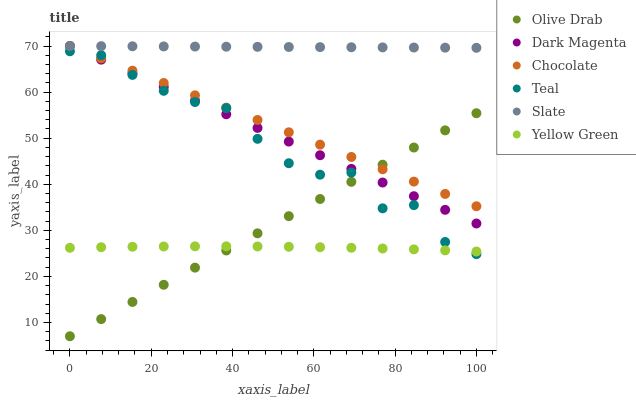Does Yellow Green have the minimum area under the curve?
Answer yes or no. Yes. Does Slate have the maximum area under the curve?
Answer yes or no. Yes. Does Chocolate have the minimum area under the curve?
Answer yes or no. No. Does Chocolate have the maximum area under the curve?
Answer yes or no. No. Is Olive Drab the smoothest?
Answer yes or no. Yes. Is Teal the roughest?
Answer yes or no. Yes. Is Slate the smoothest?
Answer yes or no. No. Is Slate the roughest?
Answer yes or no. No. Does Olive Drab have the lowest value?
Answer yes or no. Yes. Does Chocolate have the lowest value?
Answer yes or no. No. Does Dark Magenta have the highest value?
Answer yes or no. Yes. Does Teal have the highest value?
Answer yes or no. No. Is Yellow Green less than Dark Magenta?
Answer yes or no. Yes. Is Dark Magenta greater than Yellow Green?
Answer yes or no. Yes. Does Chocolate intersect Dark Magenta?
Answer yes or no. Yes. Is Chocolate less than Dark Magenta?
Answer yes or no. No. Is Chocolate greater than Dark Magenta?
Answer yes or no. No. Does Yellow Green intersect Dark Magenta?
Answer yes or no. No. 